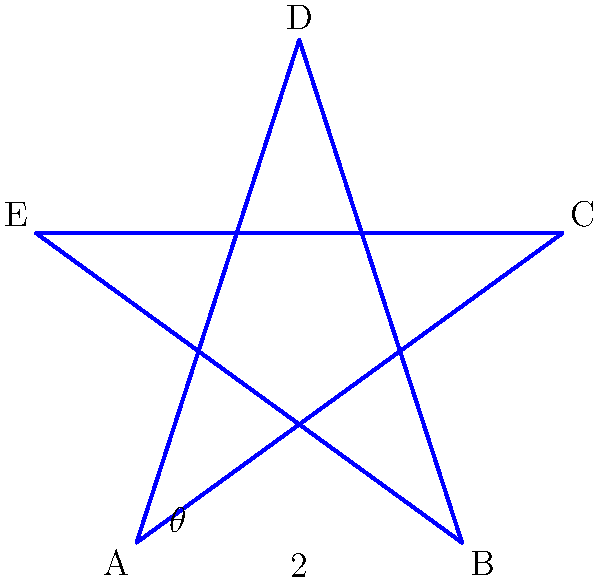In a surreal landscape inspired by Angela Carter's magical realism, you encounter a pentagram-shaped garden. The garden's mystical properties are tied to its precise measurements. If the length of one side of the pentagram is 2 units and the angle between any two adjacent sides is $\theta = 108°$, what is the area of this enigmatic garden? To find the area of the pentagram-shaped garden, we'll follow these steps:

1) First, we need to recognize that a pentagram consists of five congruent isosceles triangles.

2) We can calculate the area of one of these triangles and then multiply by 5 to get the total area.

3) In each isosceles triangle:
   - The base is 2 units (given)
   - The angle between the two equal sides is $108°$ (given)

4) To find the height of the isosceles triangle, we can use the formula:
   $h = \frac{b}{2} \tan(\frac{\theta}{2})$
   where $b$ is the base and $\theta$ is the angle between the equal sides.

5) Plugging in our values:
   $h = \frac{2}{2} \tan(\frac{108°}{2}) = \tan(54°) \approx 1.376$

6) Now we can calculate the area of one triangle:
   $A_{triangle} = \frac{1}{2} \cdot base \cdot height = \frac{1}{2} \cdot 2 \cdot 1.376 = 1.376$

7) The total area of the pentagram is 5 times this:
   $A_{pentagram} = 5 \cdot 1.376 = 6.88$ square units

Thus, the area of the enigmatic pentagram-shaped garden is approximately 6.88 square units.
Answer: $6.88$ square units 